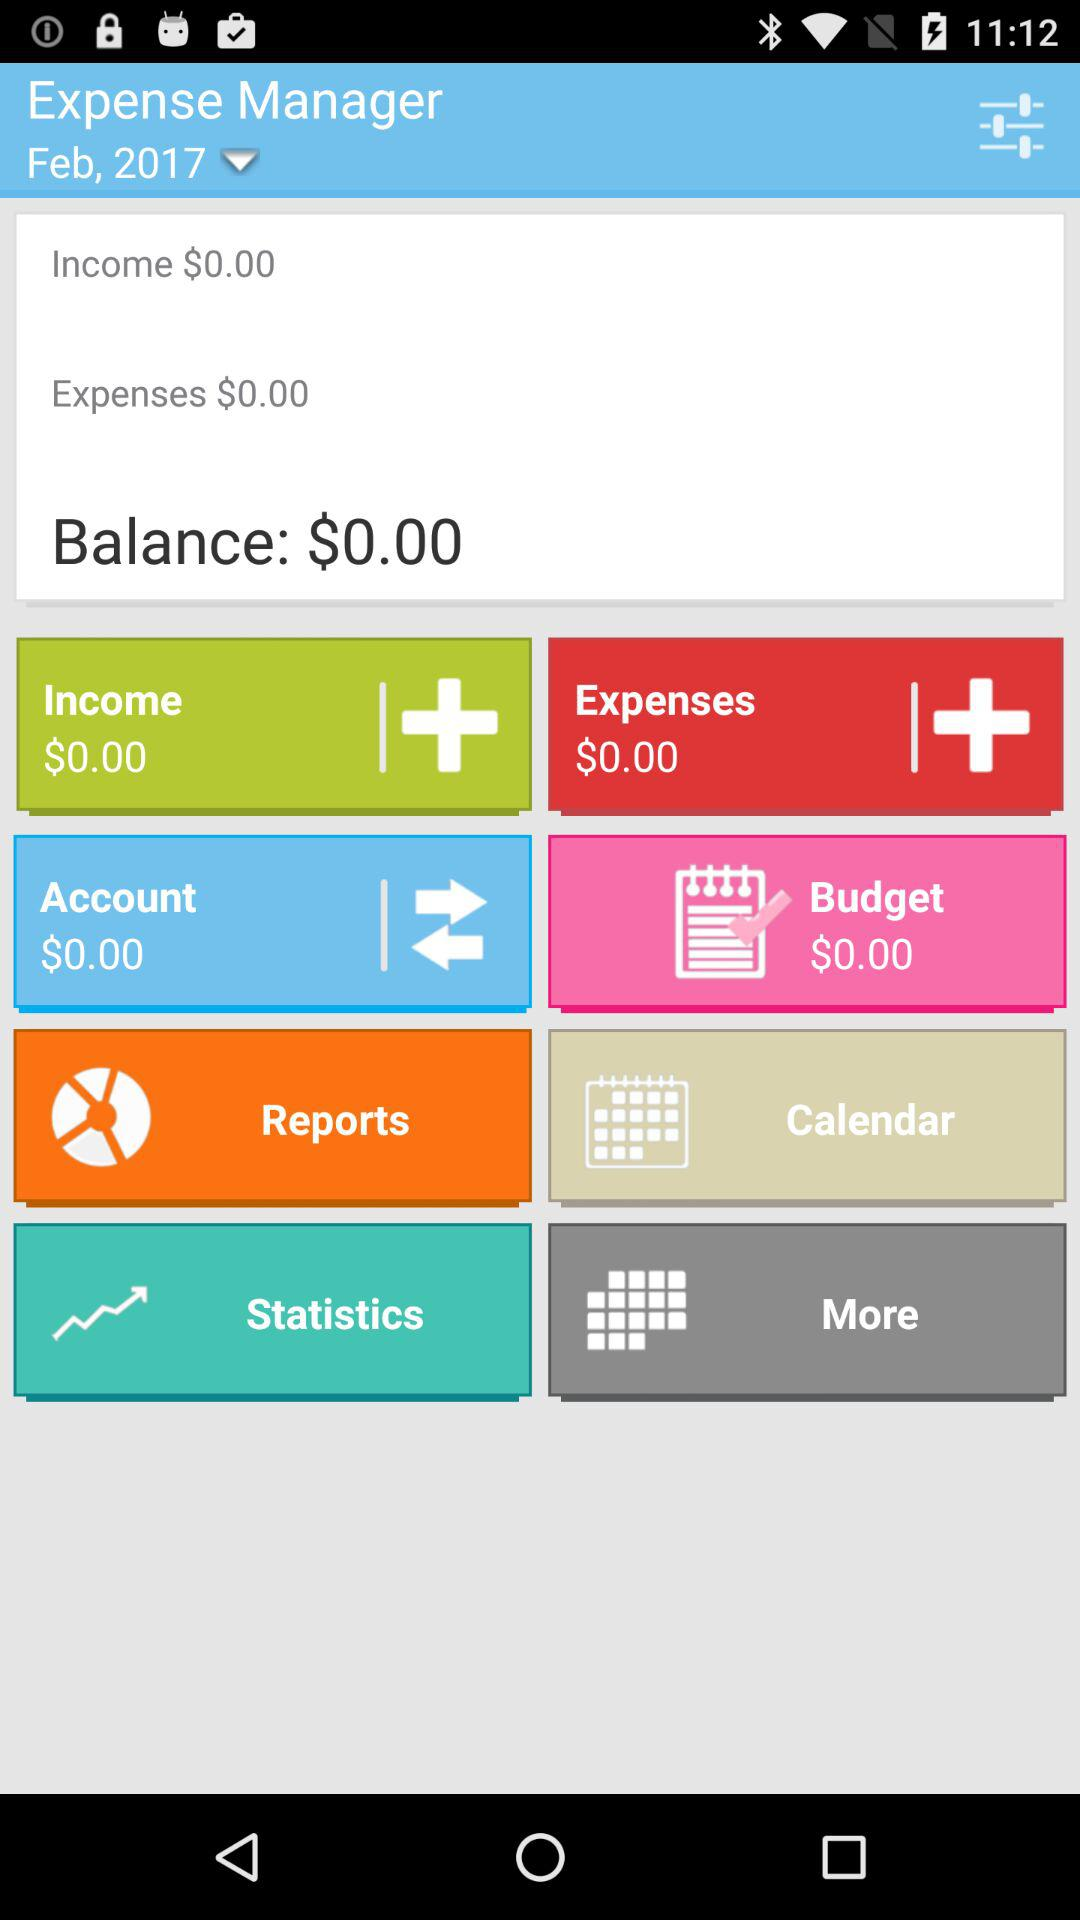What is the total amount of money spent on expenses and income?
Answer the question using a single word or phrase. $0.00 